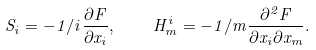Convert formula to latex. <formula><loc_0><loc_0><loc_500><loc_500>S _ { i } = - 1 / i \frac { \partial { F } } { \partial { x _ { i } } } , \quad H _ { m } ^ { i } = - 1 / m \frac { \partial ^ { 2 } { F } } { \partial { x _ { i } } \partial { x _ { m } } } .</formula> 